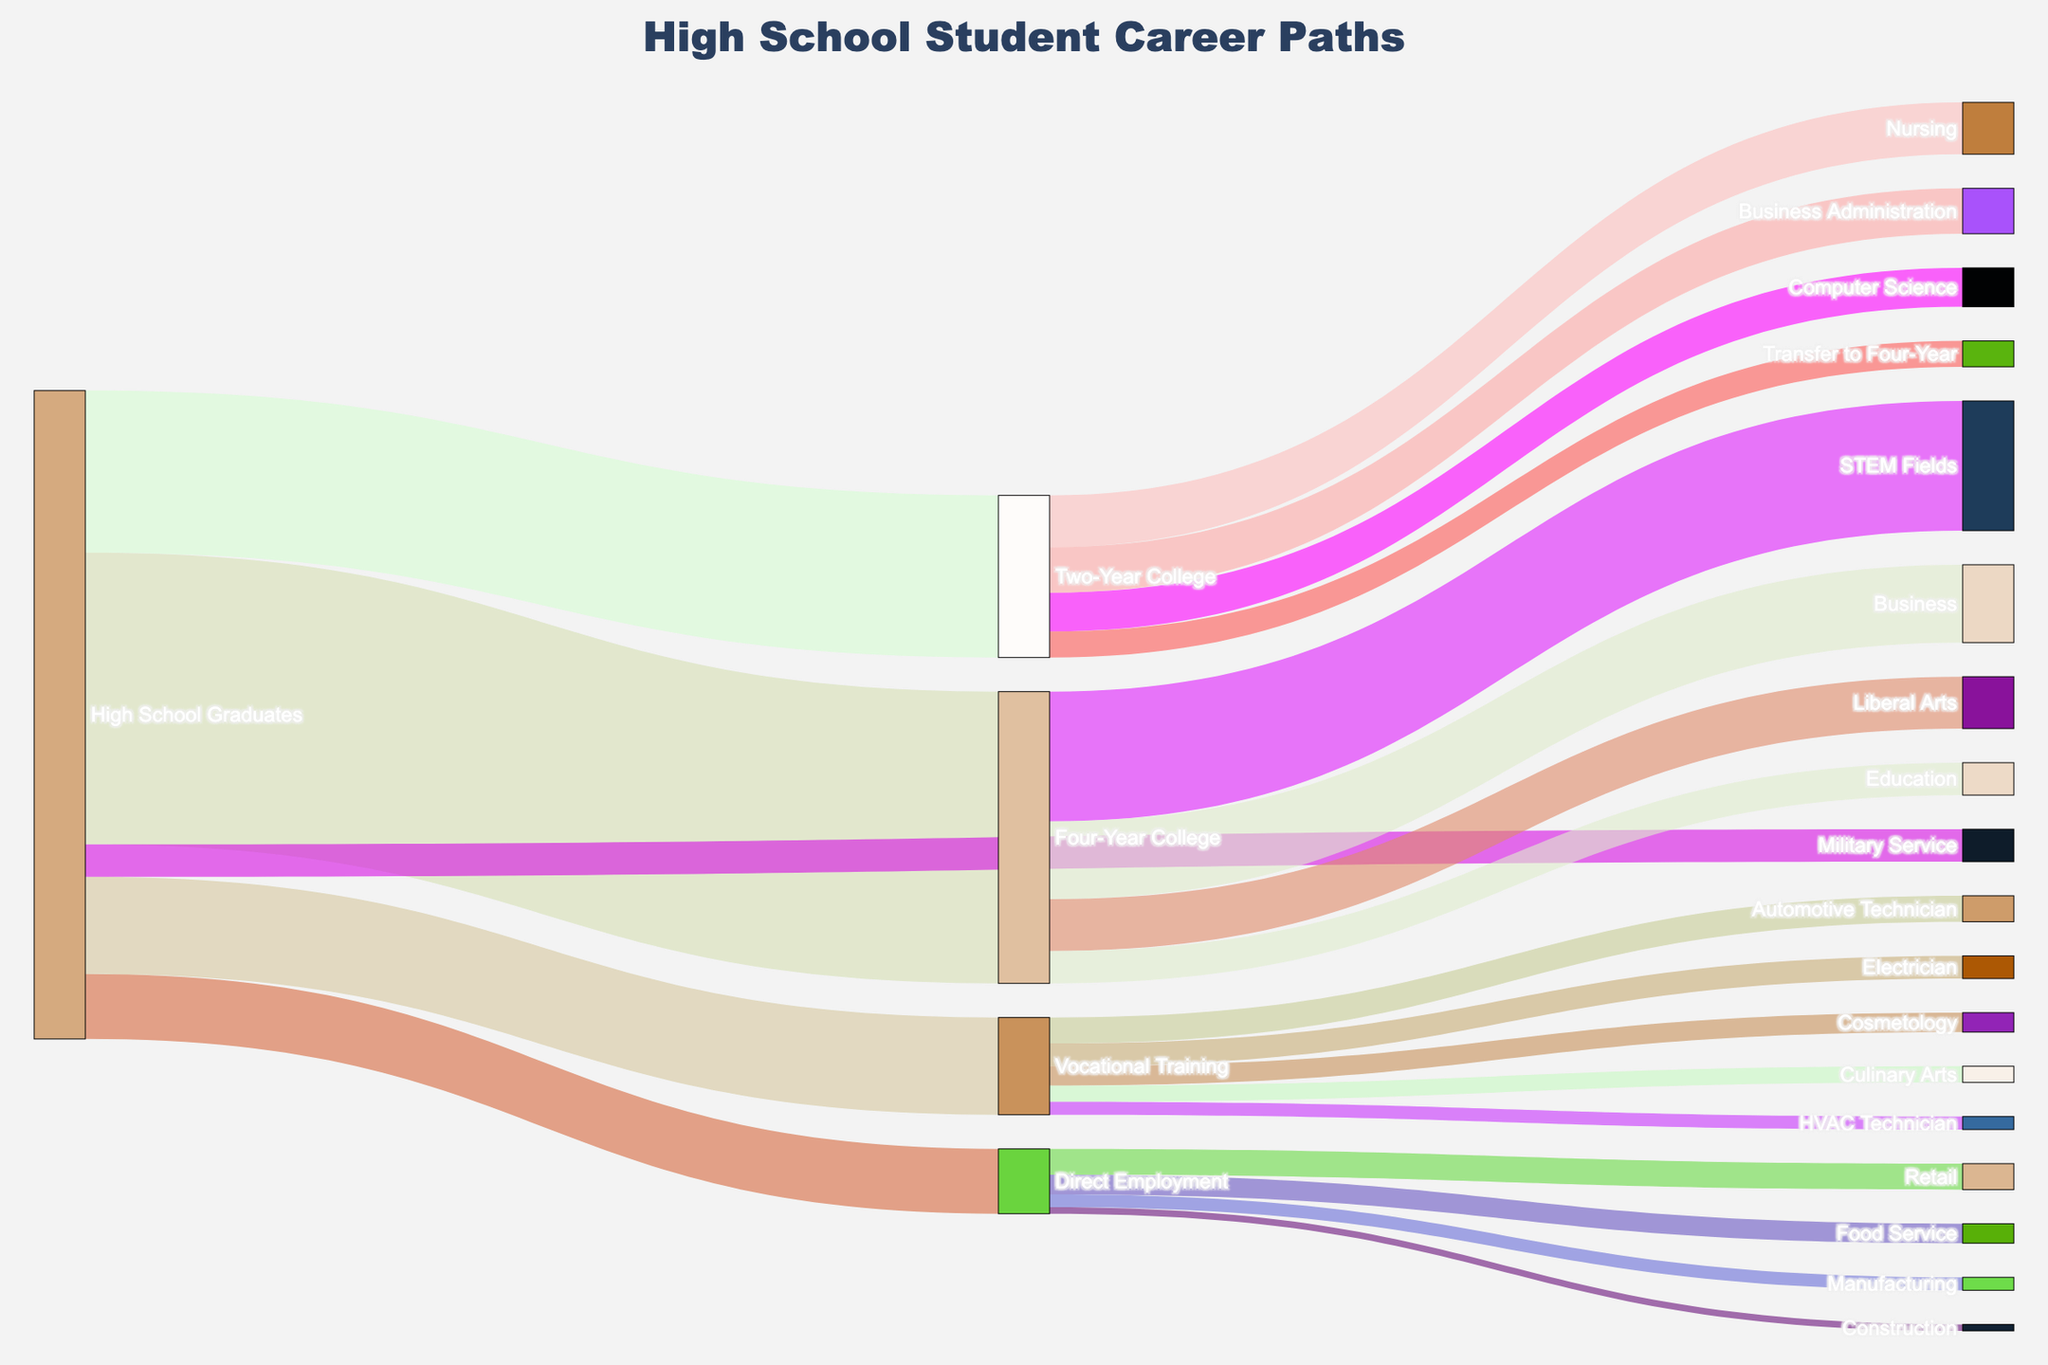What's the title of the Sankey Diagram? The title is usually located at the top of the Sankey Diagram, often using a larger and bolder font size. In this case, the title is "High School Student Career Paths."
Answer: High School Student Career Paths How many students opted for vocational training after high school? The number of students for each path is indicated by the thickness of the corresponding link. According to the provided data, 150 students chose vocational training.
Answer: 150 Which career path had the most students right after high school? By comparing the thickness of the initial links from "High School Graduates," the link labeled "Four-Year College" is the thickest, indicating 450 students.
Answer: Four-Year College What is the combined total of students who pursued some form of higher education (Four-Year College + Two-Year College) after high school? We need to add the values of students who went to Four-Year College and Two-Year College. From the data, 450 students went to Four-Year College and 250 went to Two-Year College: 450 + 250 = 700.
Answer: 700 How many students pursued direct employment right after high school? The data points to 100 students opting for direct employment. This can be seen as the number linked directly from "High School Graduates" to "Direct Employment."
Answer: 100 Which field within the vocational training category had the least number of students? By comparing the thickness of the links from "Vocational Training," the link labeled "HVAC Technician" is the thinnest, corresponding to 20 students.
Answer: HVAC Technician Compare the numbers of students who went into STEM fields versus Business from Four-Year College graduates. Which is higher, and by how much? The number of students in STEM from Four-Year College is 200, and in Business, it is 120. We subtract the smaller value from the larger to find the difference: 200 - 120 = 80.
Answer: STEM by 80 How many students from Two-Year College transferred to a Four-Year College? The link labeled "Transfer to Four-Year" from "Two-Year College" represents 40 students who transferred.
Answer: 40 What is the total number of students who chose Nursing and Computer Science from Two-Year College? Add the number of students in Nursing (80) and Computer Science (60): 80 + 60 = 140.
Answer: 140 How many more students chose Retail over Construction in direct employment? The data shows that 40 students chose Retail, while 10 chose Construction. Subtract the number for Construction from the number for Retail: 40 - 10 = 30.
Answer: 30 